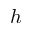<formula> <loc_0><loc_0><loc_500><loc_500>h</formula> 